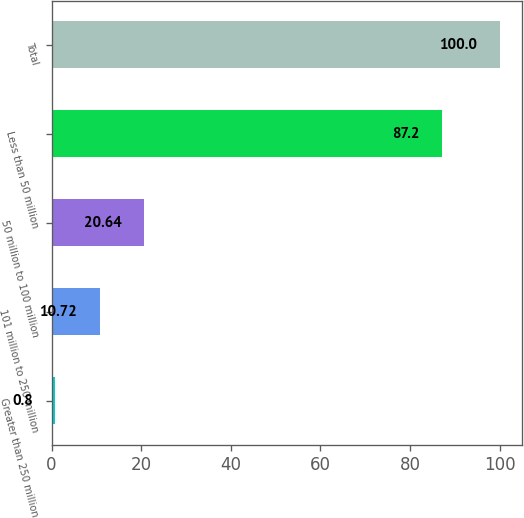Convert chart. <chart><loc_0><loc_0><loc_500><loc_500><bar_chart><fcel>Greater than 250 million<fcel>101 million to 250 million<fcel>50 million to 100 million<fcel>Less than 50 million<fcel>Total<nl><fcel>0.8<fcel>10.72<fcel>20.64<fcel>87.2<fcel>100<nl></chart> 